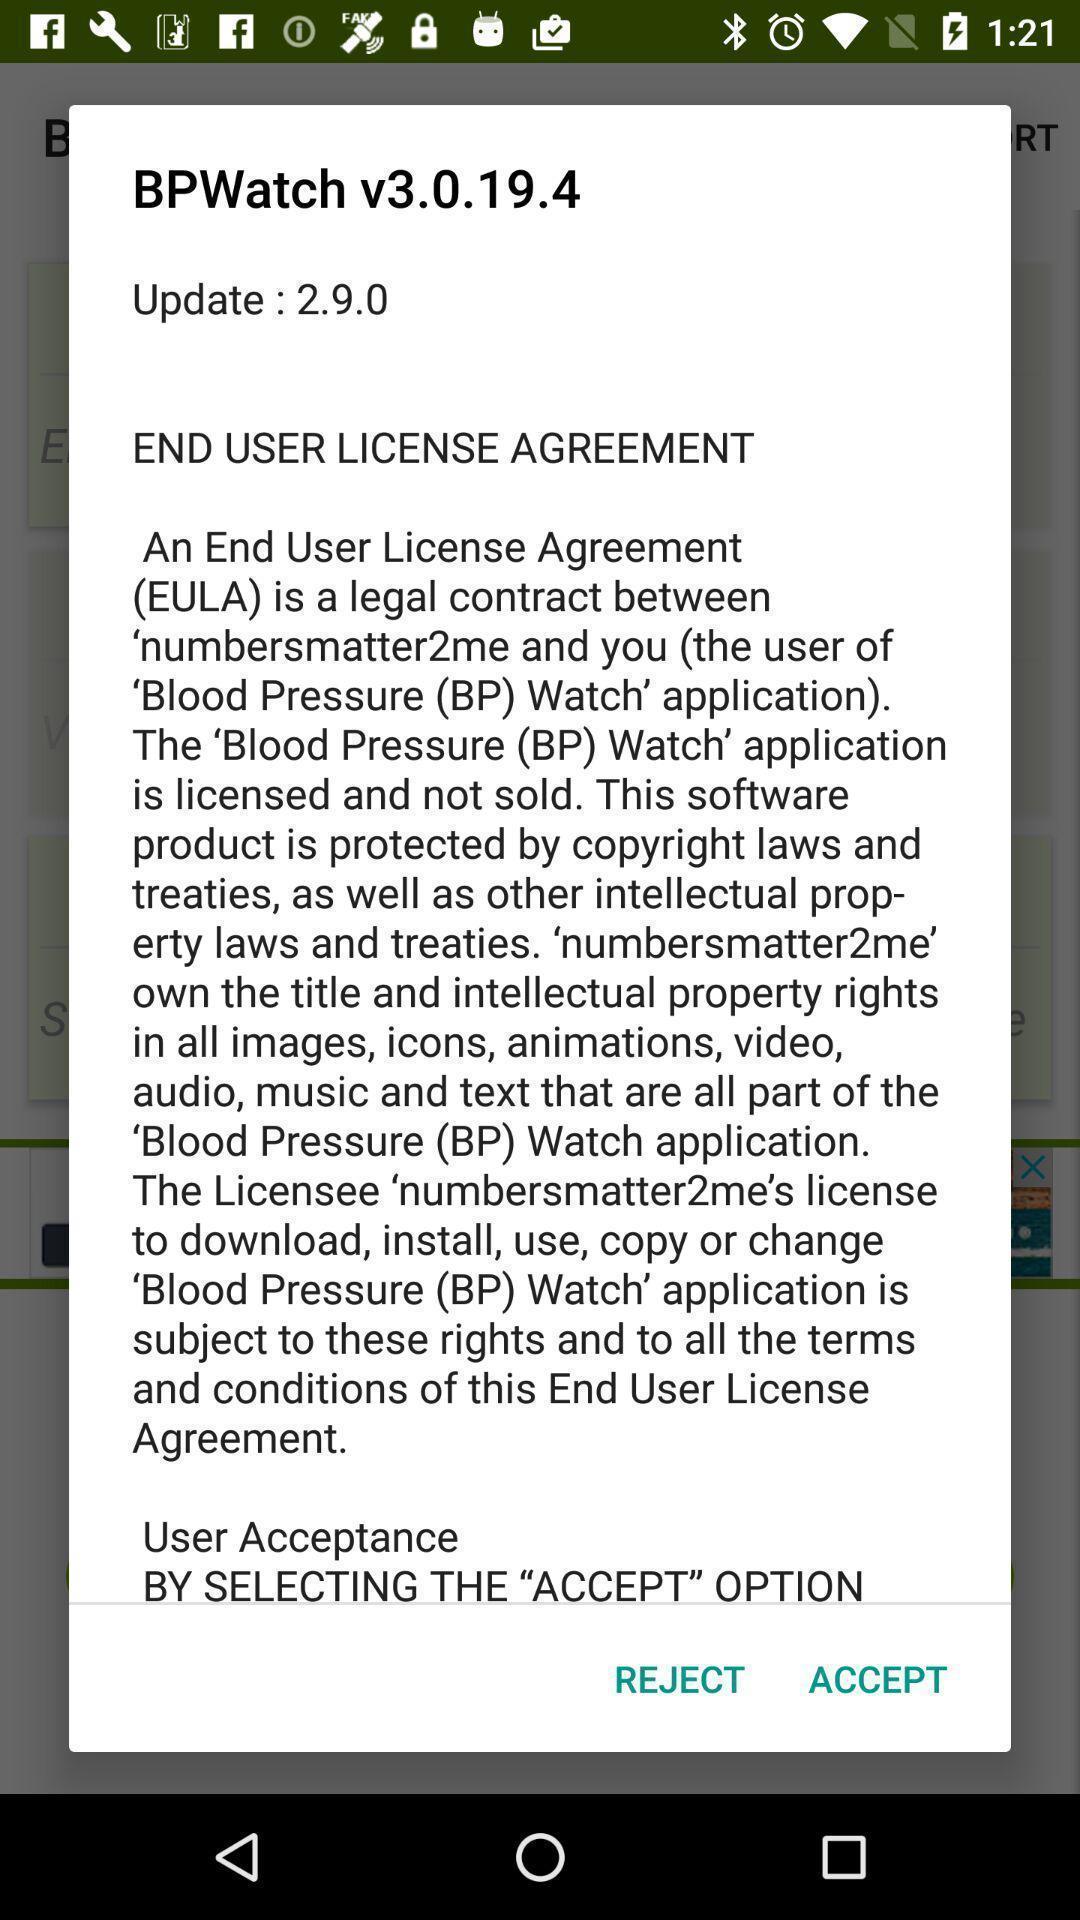Tell me what you see in this picture. Popup showing accept and reject options. 